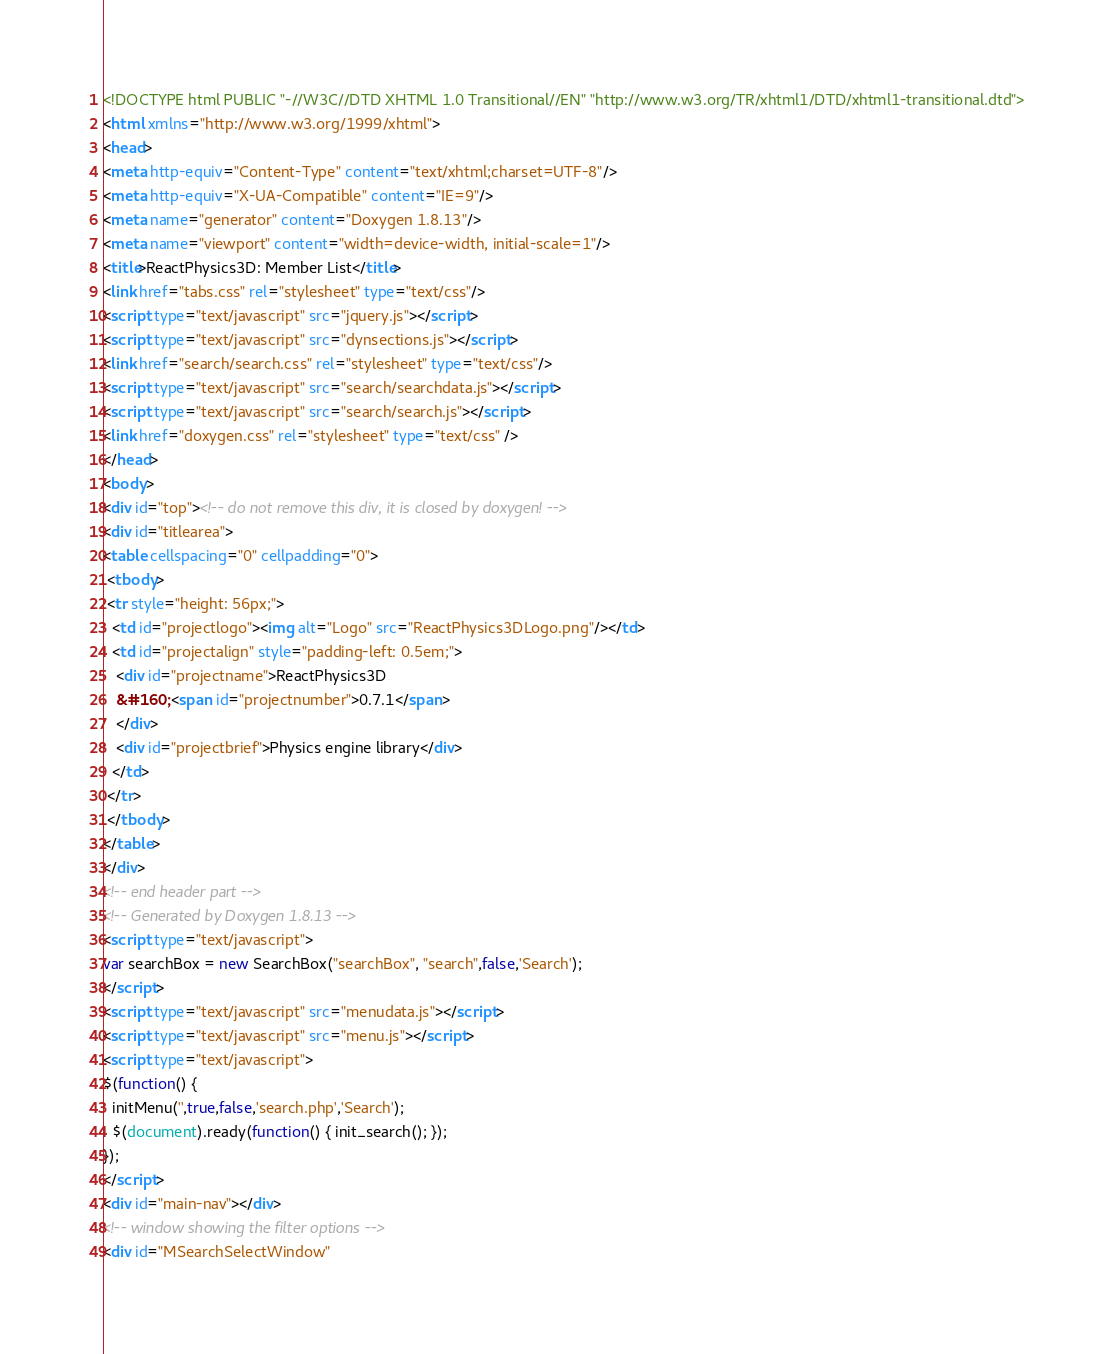<code> <loc_0><loc_0><loc_500><loc_500><_HTML_><!DOCTYPE html PUBLIC "-//W3C//DTD XHTML 1.0 Transitional//EN" "http://www.w3.org/TR/xhtml1/DTD/xhtml1-transitional.dtd">
<html xmlns="http://www.w3.org/1999/xhtml">
<head>
<meta http-equiv="Content-Type" content="text/xhtml;charset=UTF-8"/>
<meta http-equiv="X-UA-Compatible" content="IE=9"/>
<meta name="generator" content="Doxygen 1.8.13"/>
<meta name="viewport" content="width=device-width, initial-scale=1"/>
<title>ReactPhysics3D: Member List</title>
<link href="tabs.css" rel="stylesheet" type="text/css"/>
<script type="text/javascript" src="jquery.js"></script>
<script type="text/javascript" src="dynsections.js"></script>
<link href="search/search.css" rel="stylesheet" type="text/css"/>
<script type="text/javascript" src="search/searchdata.js"></script>
<script type="text/javascript" src="search/search.js"></script>
<link href="doxygen.css" rel="stylesheet" type="text/css" />
</head>
<body>
<div id="top"><!-- do not remove this div, it is closed by doxygen! -->
<div id="titlearea">
<table cellspacing="0" cellpadding="0">
 <tbody>
 <tr style="height: 56px;">
  <td id="projectlogo"><img alt="Logo" src="ReactPhysics3DLogo.png"/></td>
  <td id="projectalign" style="padding-left: 0.5em;">
   <div id="projectname">ReactPhysics3D
   &#160;<span id="projectnumber">0.7.1</span>
   </div>
   <div id="projectbrief">Physics engine library</div>
  </td>
 </tr>
 </tbody>
</table>
</div>
<!-- end header part -->
<!-- Generated by Doxygen 1.8.13 -->
<script type="text/javascript">
var searchBox = new SearchBox("searchBox", "search",false,'Search');
</script>
<script type="text/javascript" src="menudata.js"></script>
<script type="text/javascript" src="menu.js"></script>
<script type="text/javascript">
$(function() {
  initMenu('',true,false,'search.php','Search');
  $(document).ready(function() { init_search(); });
});
</script>
<div id="main-nav"></div>
<!-- window showing the filter options -->
<div id="MSearchSelectWindow"</code> 